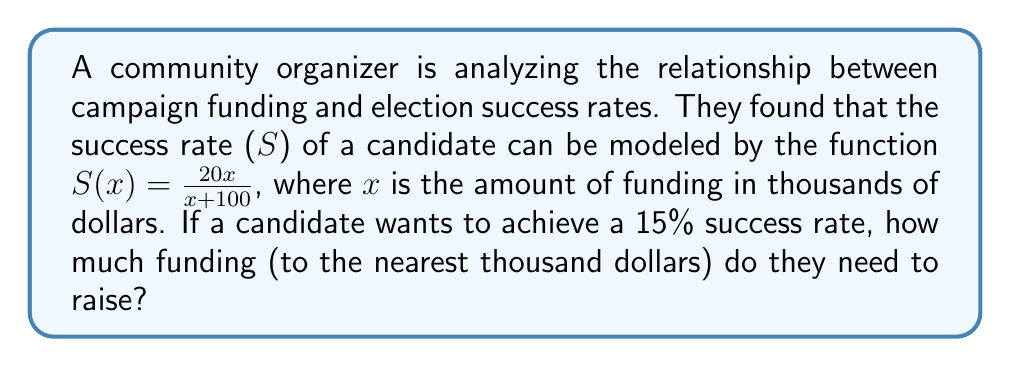Can you solve this math problem? 1) We start with the given function: $S(x) = \frac{20x}{x+100}$

2) We want to find x when S(x) = 15% = 0.15

3) Let's substitute this into our equation:
   $0.15 = \frac{20x}{x+100}$

4) Multiply both sides by (x+100):
   $0.15(x+100) = 20x$

5) Expand the left side:
   $0.15x + 15 = 20x$

6) Subtract 0.15x from both sides:
   $15 = 19.85x$

7) Divide both sides by 19.85:
   $x = \frac{15}{19.85} \approx 0.7557$

8) Remember, x is in thousands of dollars, so we need to multiply by 1000:
   $0.7557 * 1000 = 755.7$

9) Rounding to the nearest thousand dollars:
   $755.7 \approx 1000$
Answer: $1000 